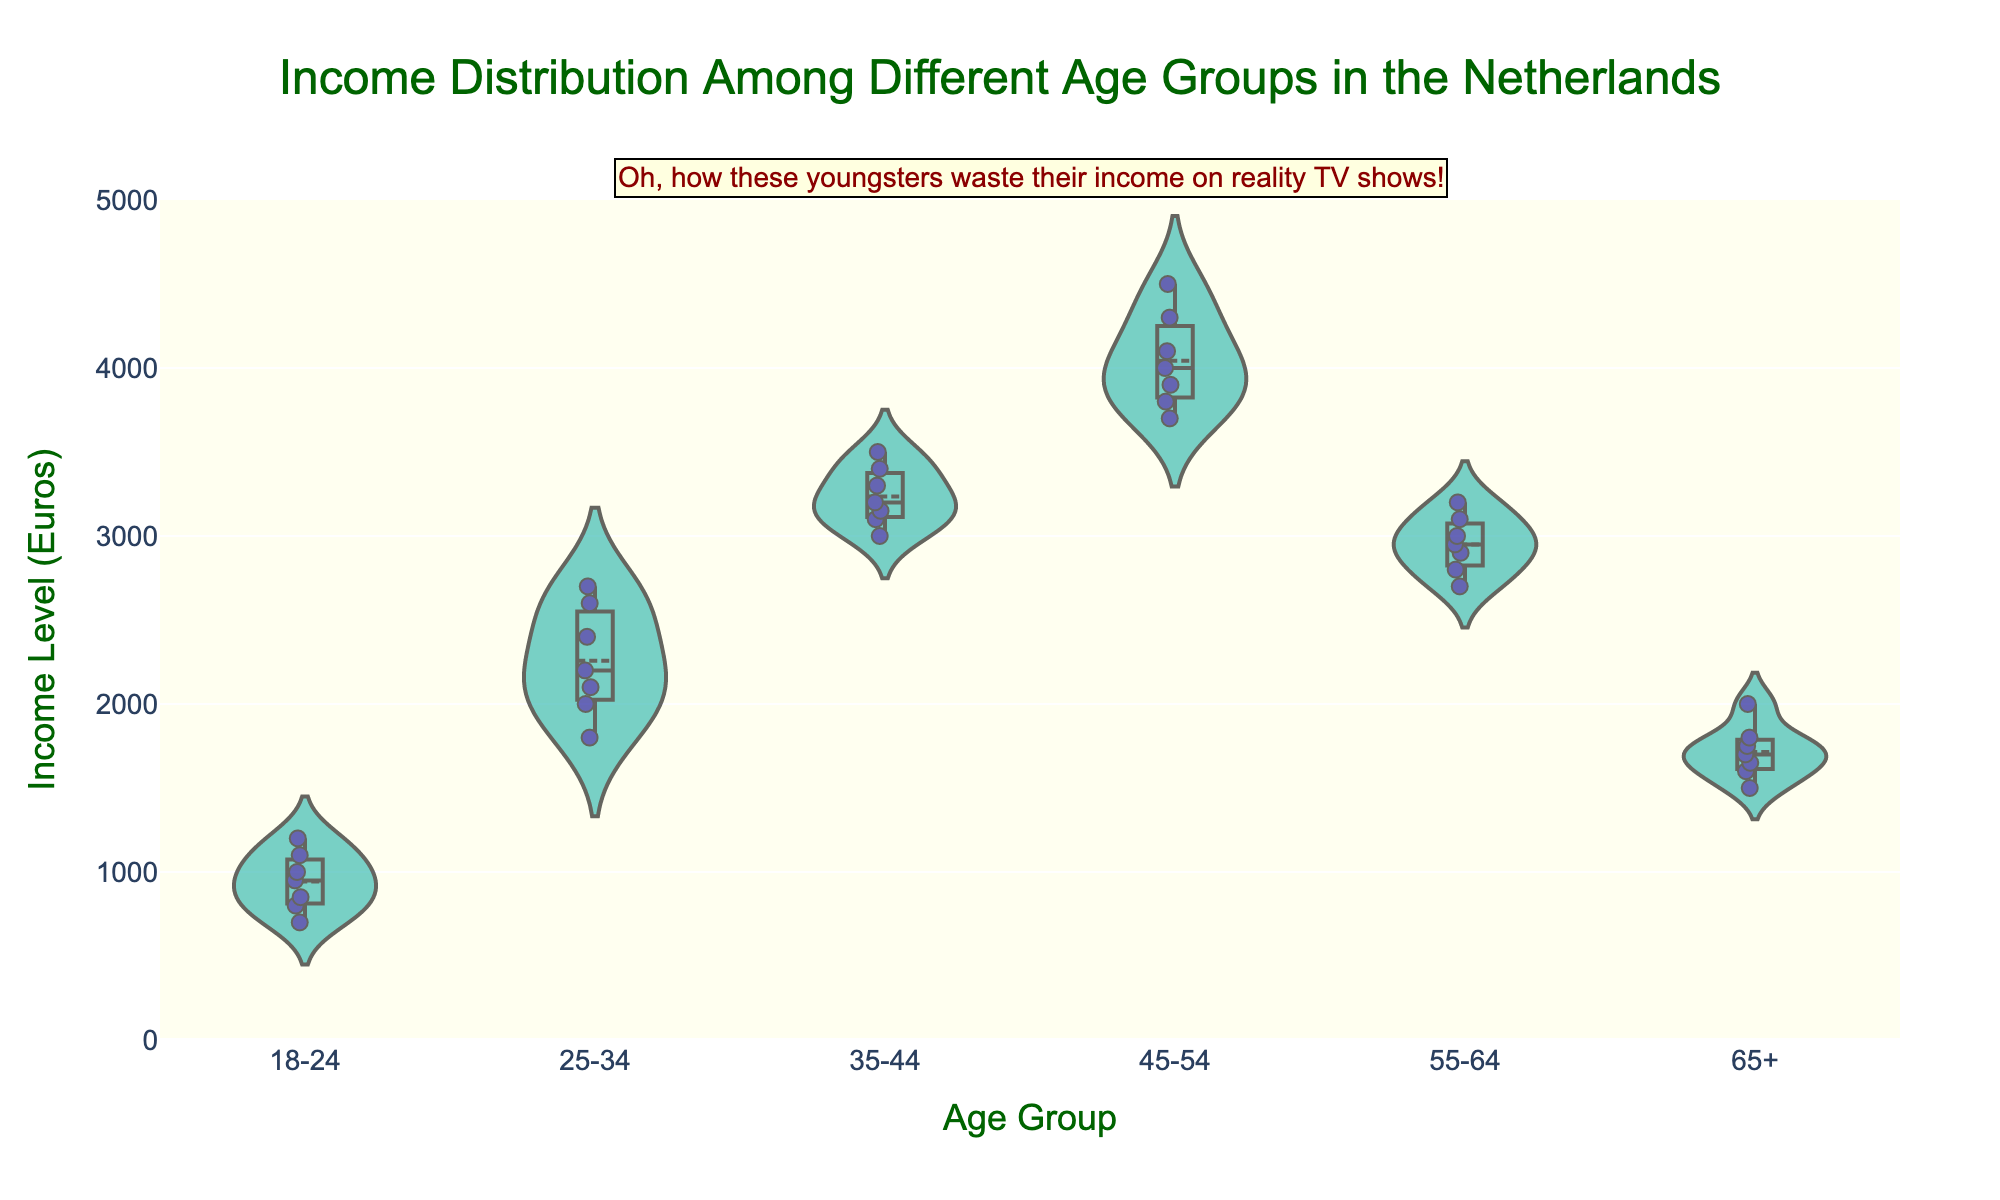What is the title of the figure? The title of the figure is located at the top and is a summary of what the visual represents.
Answer: Income Distribution Among Different Age Groups in the Netherlands Which age group shows the highest median income level? The median for each group is typically represented by a line within the violin plot. The 45-54 age group is the highest.
Answer: 45-54 What is the lowest income level recorded for the age group 18-24? To find the minimum income level for 18-24, look for the lowest data point in that particular violin plot.
Answer: 700 Euros Which age group has the widest spread in income levels? The age group with the widest spread has the largest vertical height in its violin plot.
Answer: 45-54 Are there any age groups with outliers in their income distribution? Outliers appear as individual points outside the main bulk of the data in a violin plot. The 25-34 age group has a couple of outliers.
Answer: Yes, 25-34 How does the mean income level of the 35-44 age group compare to that of the 55-64 age group? Each violin plot shows a line for the mean income. Comparing these lines for the 35-44 and 55-64 age groups, the 35-44 group's mean is higher.
Answer: Mean is higher in the 35-44 age group What is the range of income levels for the 65+ age group? Determine the range by subtracting the lowest income level from the highest in the 65+ violin plot. The range is 2000 - 1500.
Answer: 500 Euros How do the interquartile ranges (IQR) differ between the 25-34 and 55-64 age groups? The IQR can be roughly estimated by looking at the width of the violin plot between the 25th and 75th percentiles. The 25-34 age group has a larger IQR compared to the 55-64 age group.
Answer: Larger in the 25-34 age group Which age group has the narrowest distribution of income levels? The age group with the smallest vertical spread indicates the narrowest income distribution.
Answer: 18-24 What is the annotation on the plot meant to highlight? The annotation is a textual addition to the plot meant to draw attention or add commentary, which in this case critiques the spending habits related to reality TV shows.
Answer: Youngsters wasting income on reality TV shows 